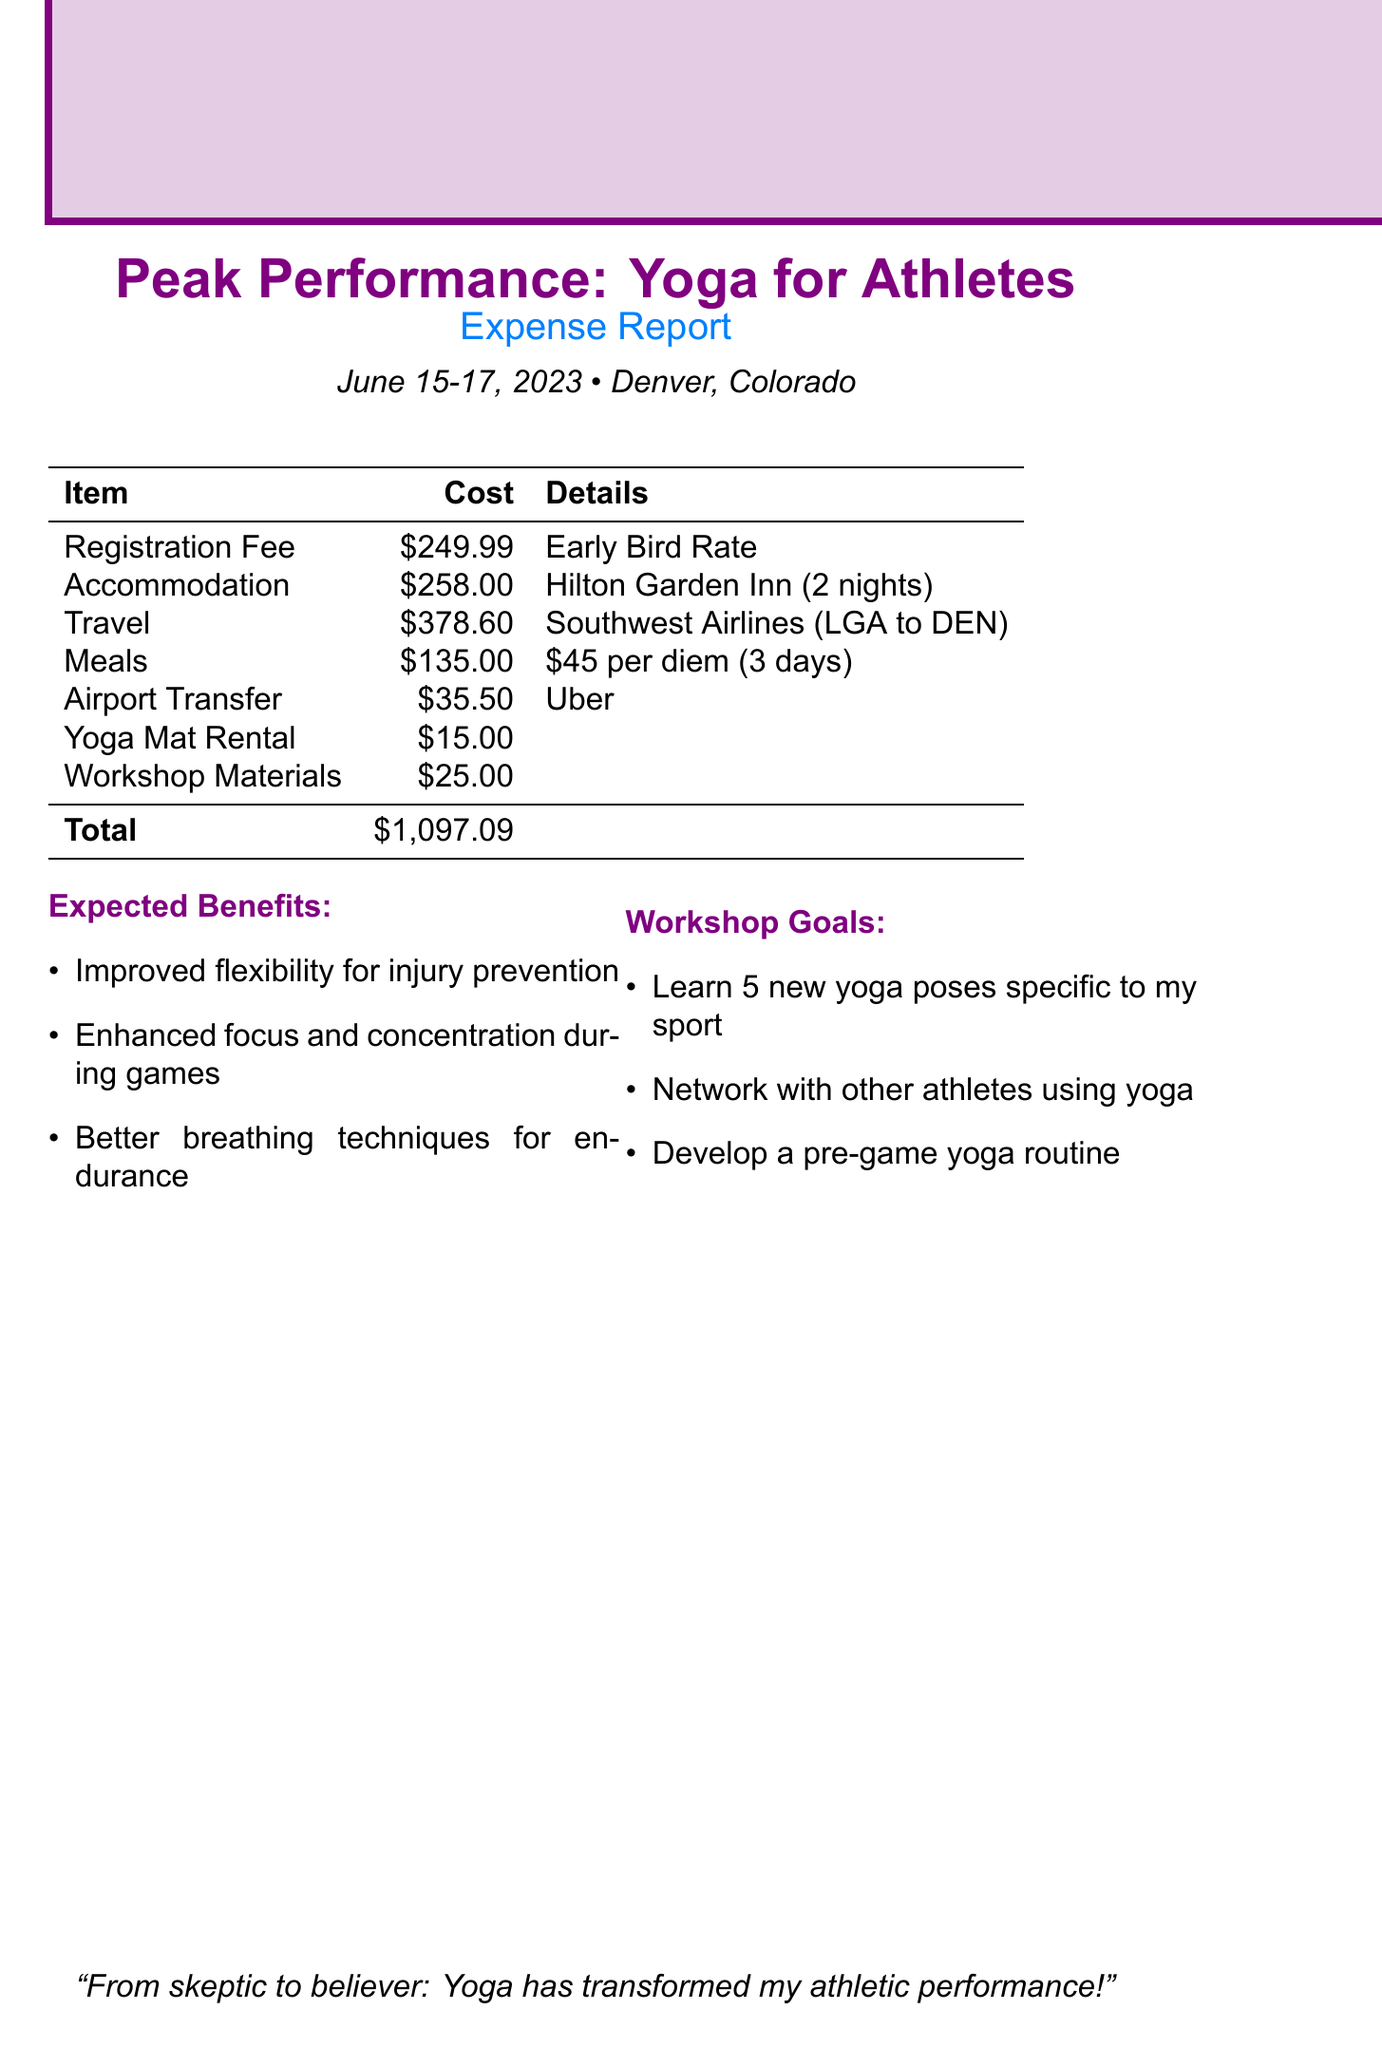What is the name of the workshop? The name of the workshop is stated in the document as "Peak Performance: Yoga for Athletes."
Answer: Peak Performance: Yoga for Athletes What is the early bird registration fee? The early bird registration fee is specified in the document as $249.99.
Answer: $249.99 How many nights will the accommodation be paid for? The document indicates that the accommodation is for 2 nights.
Answer: 2 nights What is the transportation method used? The document mentions "Southwest Airlines" as the transportation method used.
Answer: Southwest Airlines What is the total cost of the workshop expenses? The total cost is calculated by summing all listed expenses in the document, resulting in $1,097.09.
Answer: $1,097.09 What hotel will the accommodation be at? The document lists "Hilton Garden Inn Denver Downtown" as the accommodation hotel.
Answer: Hilton Garden Inn Denver Downtown What meal expense is budgeted per day? The document specifies a per diem meal expense of $45.00 per day.
Answer: $45.00 How much is allocated for yoga mat rental? The cost for yoga mat rental is mentioned as $15.00 in the document.
Answer: $15.00 What is one of the expected benefits of attending the workshop? The document lists several expected benefits, one of which is "Improved flexibility for injury prevention."
Answer: Improved flexibility for injury prevention 